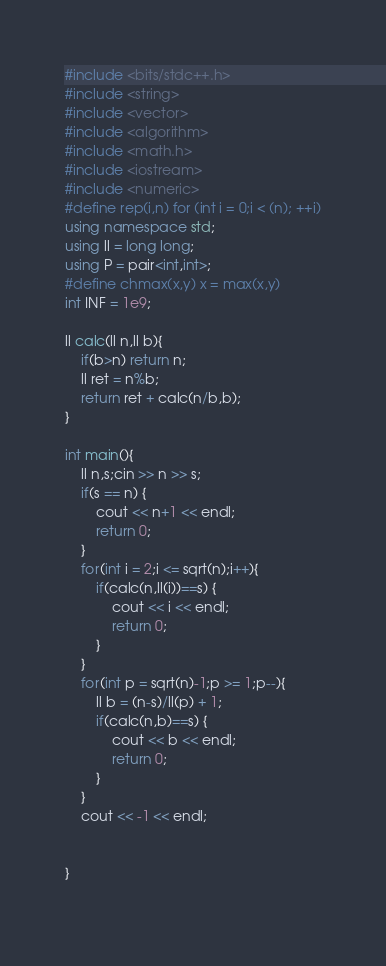<code> <loc_0><loc_0><loc_500><loc_500><_C++_>#include <bits/stdc++.h>
#include <string>
#include <vector>
#include <algorithm>
#include <math.h>
#include <iostream>
#include <numeric>
#define rep(i,n) for (int i = 0;i < (n); ++i)
using namespace std;
using ll = long long;
using P = pair<int,int>;
#define chmax(x,y) x = max(x,y)
int INF = 1e9;

ll calc(ll n,ll b){
	if(b>n) return n;
	ll ret = n%b;
	return ret + calc(n/b,b);
}

int main(){
	ll n,s;cin >> n >> s;
	if(s == n) {
		cout << n+1 << endl;
		return 0;
	}
	for(int i = 2;i <= sqrt(n);i++){
		if(calc(n,ll(i))==s) {
			cout << i << endl;
			return 0;
		}
	}
	for(int p = sqrt(n)-1;p >= 1;p--){
		ll b = (n-s)/ll(p) + 1;
		if(calc(n,b)==s) {
			cout << b << endl;
			return 0;
		}
	}
	cout << -1 << endl;
	

} 
 </code> 